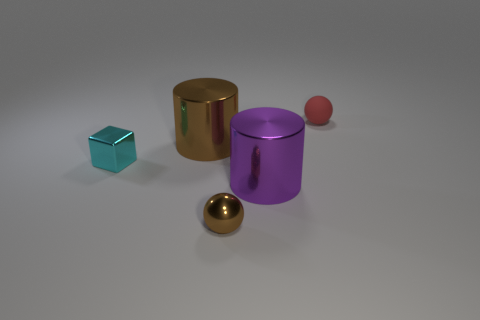Are there any other big purple metal things that have the same shape as the purple object? No, in the image, the purple object is unique in both its color and cylindrical shape. There are no other large purple metal items visible that share this specific form. 